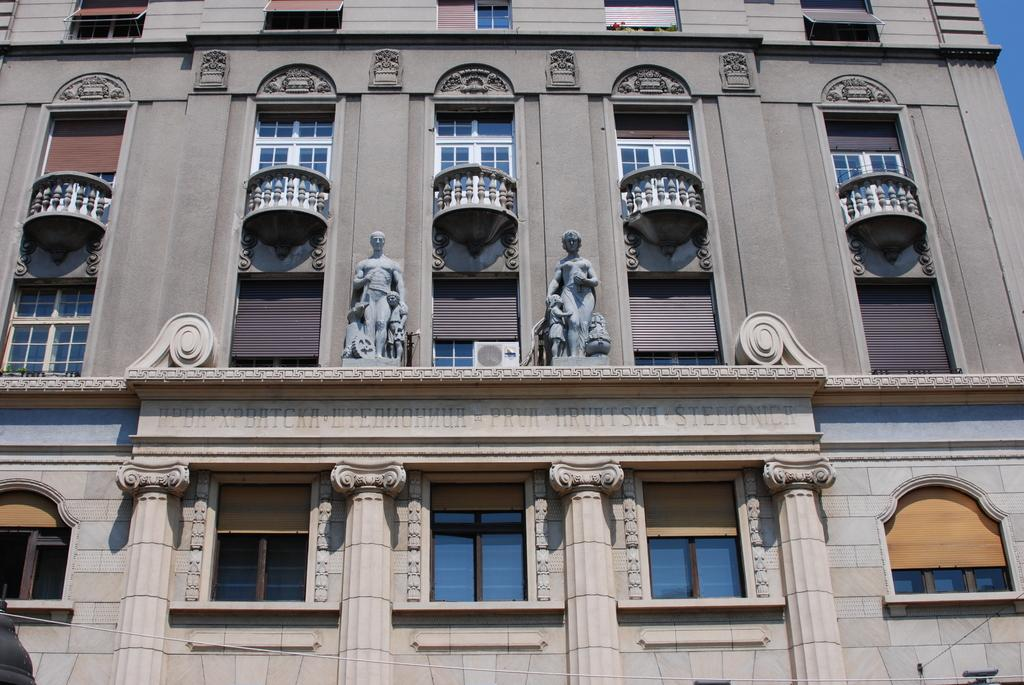What is the main subject of the image? The main subject of the image is the front view of a building. What architectural features can be seen on the building? The building has windows. Are there any additional objects or features in the image? Yes, there are statues and text visible in the image. What can be seen on the right side of the image? The sky is visible on the right side of the image. What type of jelly is being served in the image? There is no jelly present in the image; it features the front view of a building with windows, statues, text, and a visible sky. How many trucks are parked in front of the building in the image? There are no trucks visible in the image; it only shows the front view of a building with windows, statues, text, and a visible sky. 